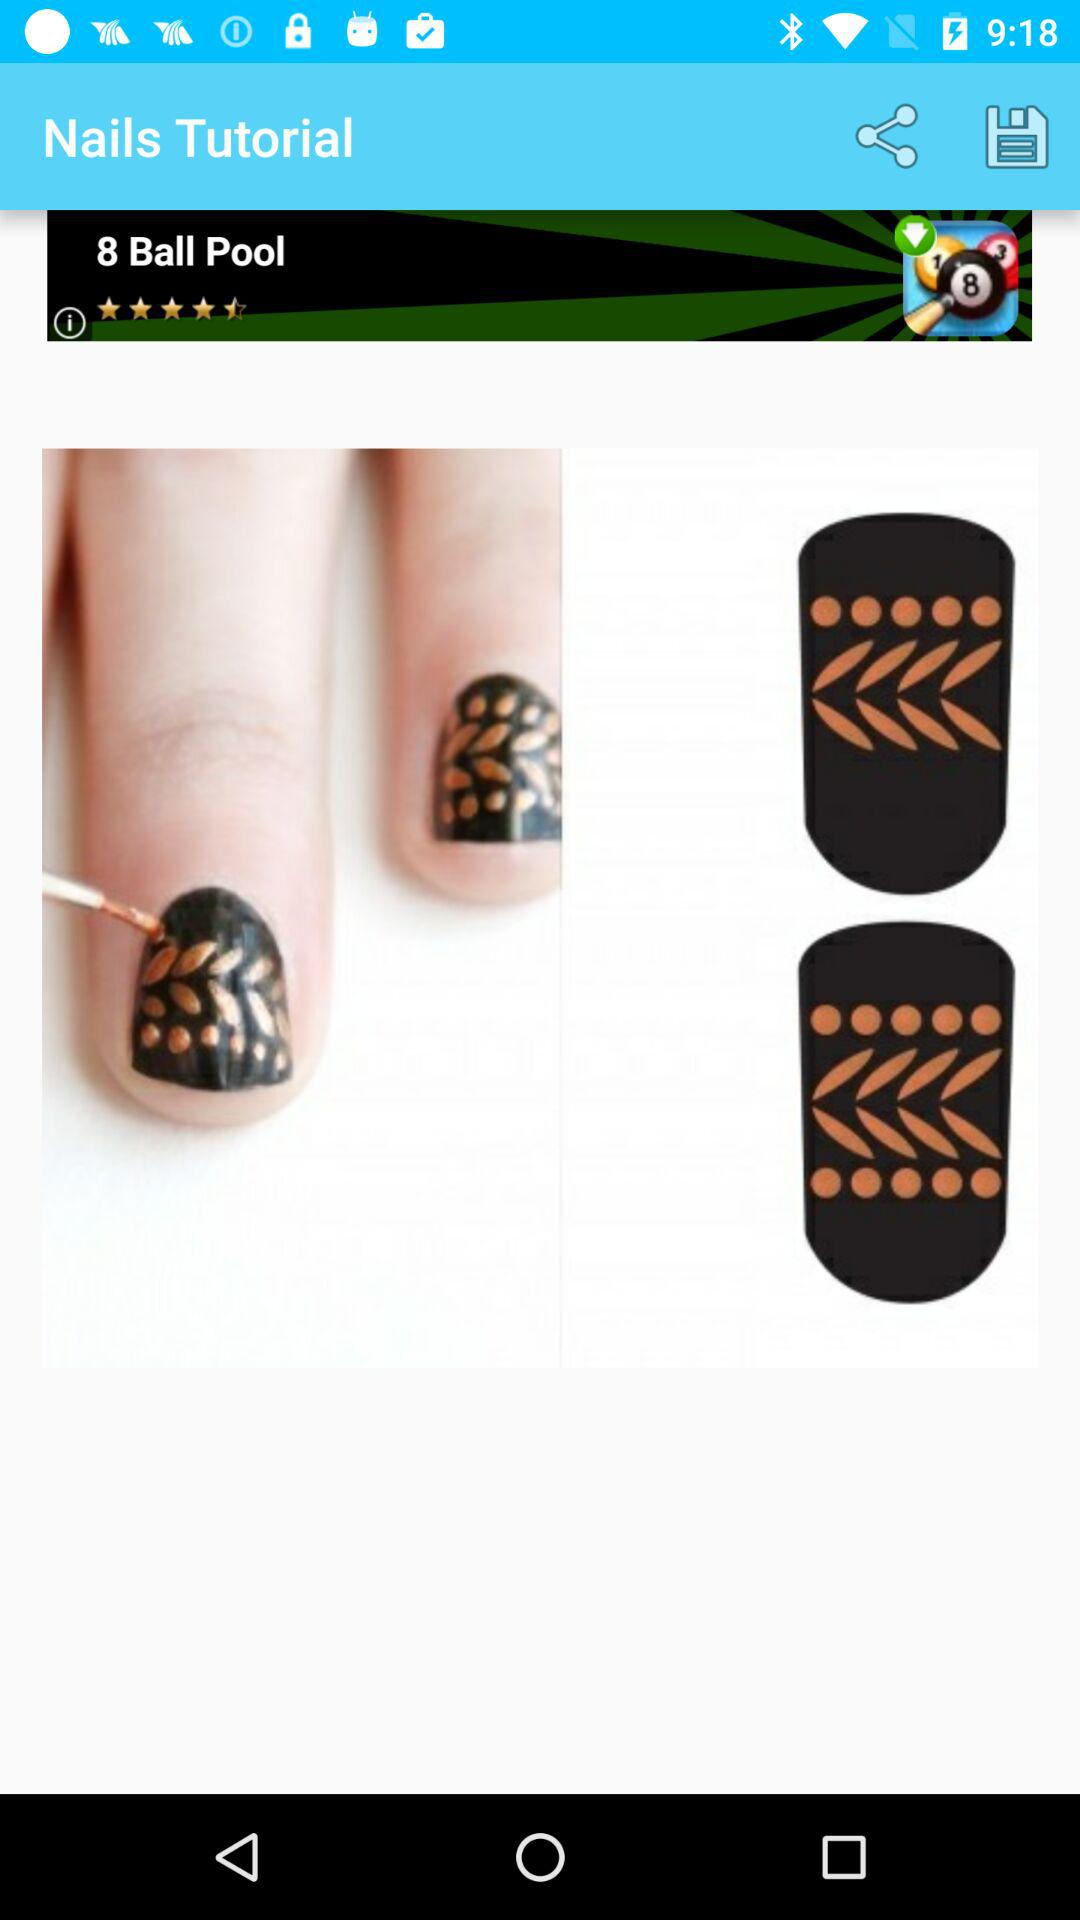What is the application name? The application name is "Nails Tutorial". 